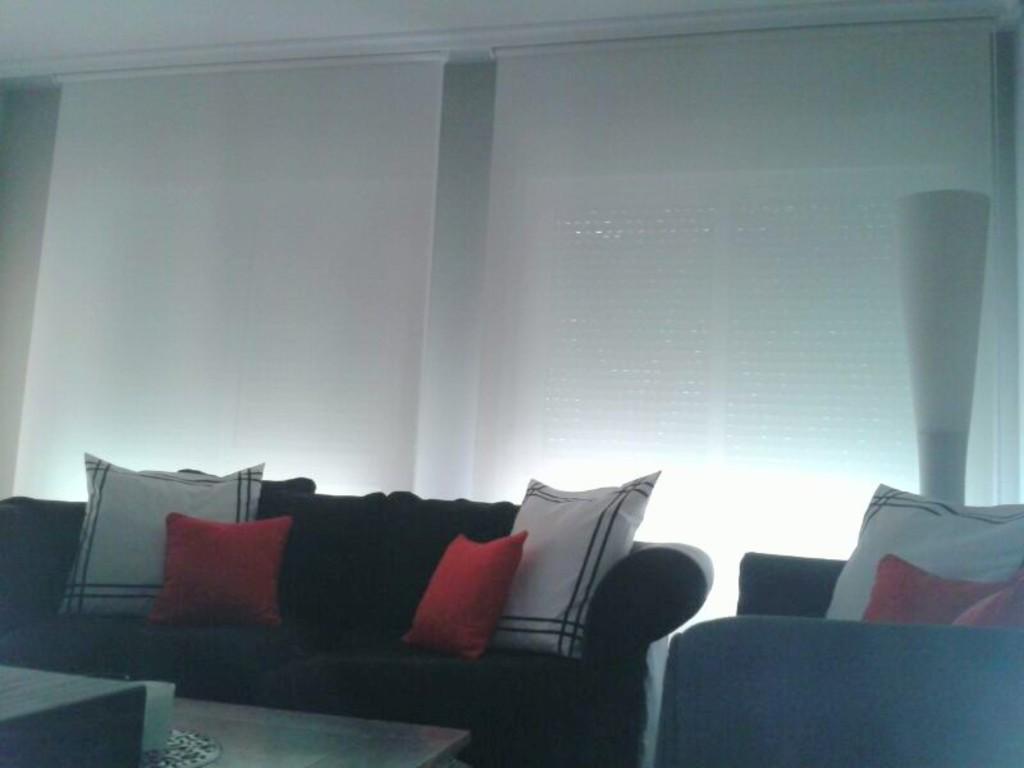In one or two sentences, can you explain what this image depicts? In this picture we can see a room with sofa pillows on it and in front of that we have table and on table we have glass and in background we can see windows. 